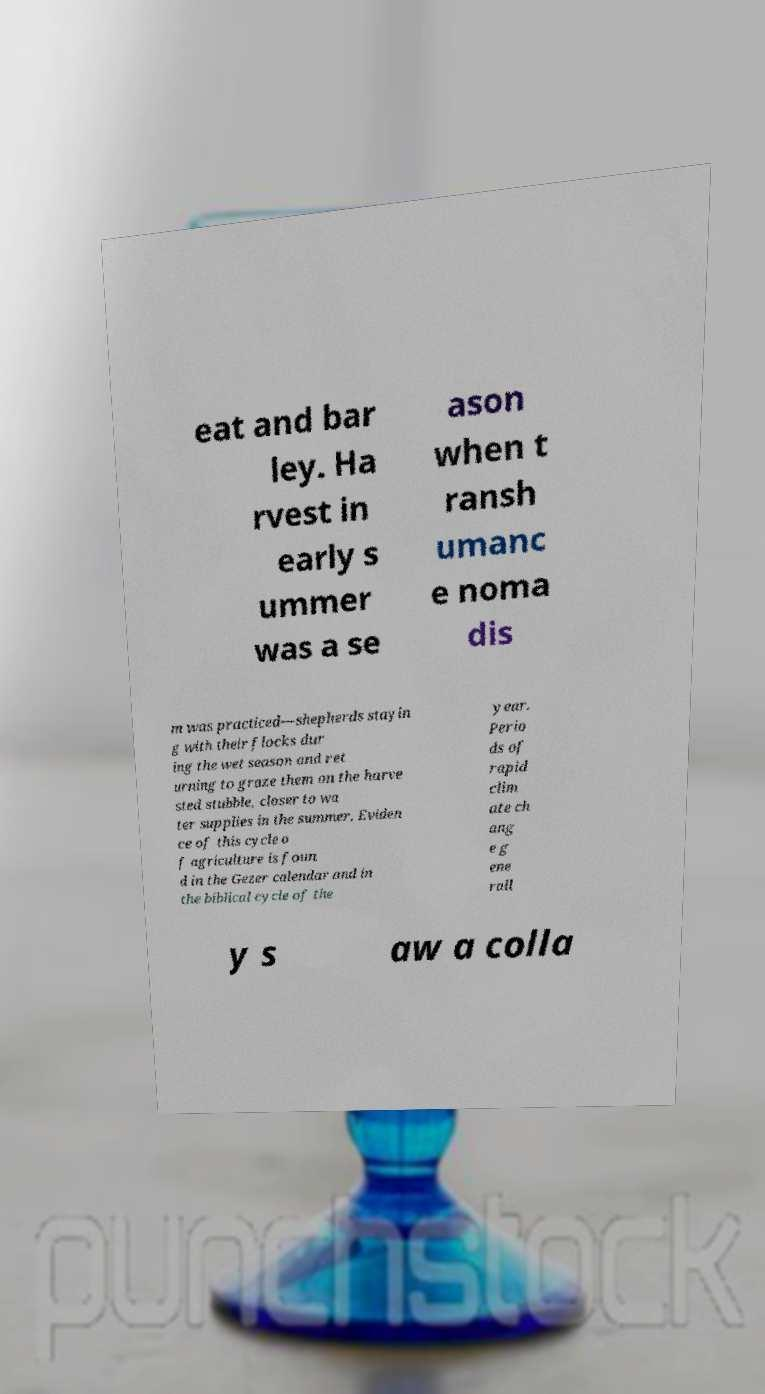Can you read and provide the text displayed in the image?This photo seems to have some interesting text. Can you extract and type it out for me? eat and bar ley. Ha rvest in early s ummer was a se ason when t ransh umanc e noma dis m was practiced—shepherds stayin g with their flocks dur ing the wet season and ret urning to graze them on the harve sted stubble, closer to wa ter supplies in the summer. Eviden ce of this cycle o f agriculture is foun d in the Gezer calendar and in the biblical cycle of the year. Perio ds of rapid clim ate ch ang e g ene rall y s aw a colla 